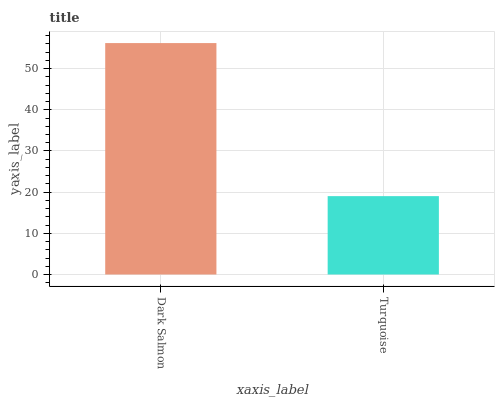Is Turquoise the maximum?
Answer yes or no. No. Is Dark Salmon greater than Turquoise?
Answer yes or no. Yes. Is Turquoise less than Dark Salmon?
Answer yes or no. Yes. Is Turquoise greater than Dark Salmon?
Answer yes or no. No. Is Dark Salmon less than Turquoise?
Answer yes or no. No. Is Dark Salmon the high median?
Answer yes or no. Yes. Is Turquoise the low median?
Answer yes or no. Yes. Is Turquoise the high median?
Answer yes or no. No. Is Dark Salmon the low median?
Answer yes or no. No. 